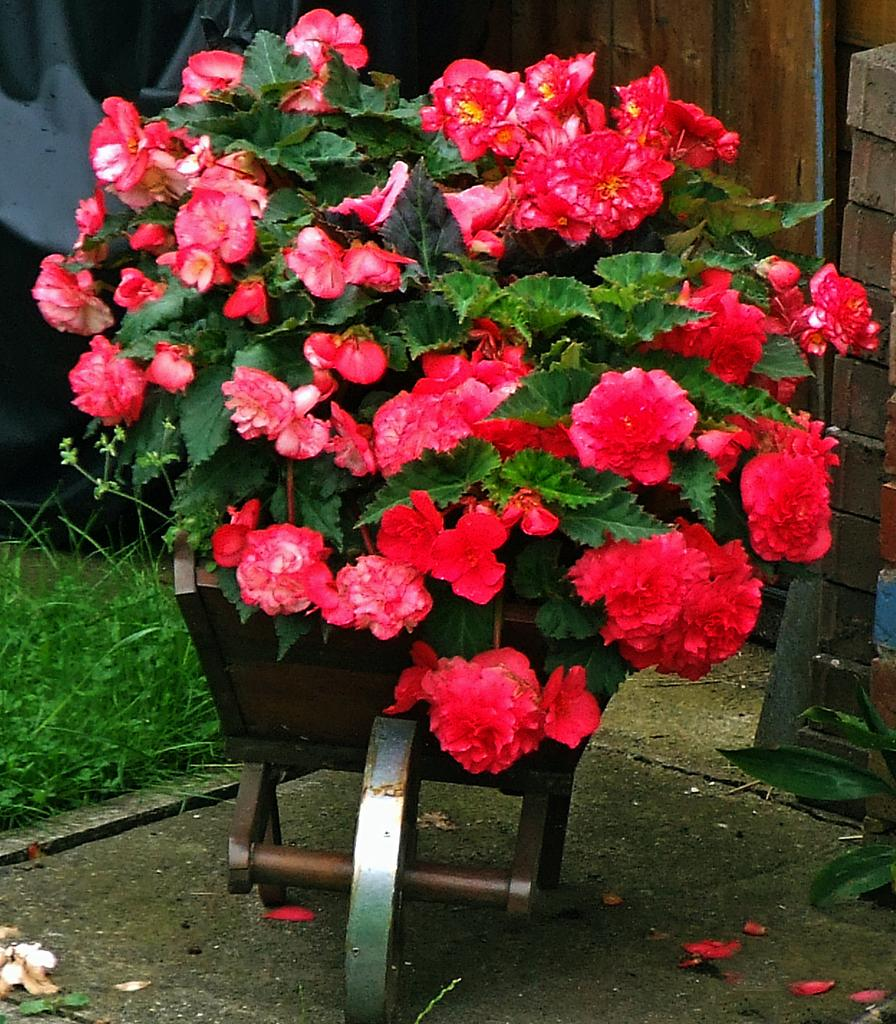What types of living organisms are in the image? There are flowers and plants in the image. How are the flowers and plants arranged in the image? The flowers and plants are in a pulley. What can be seen in the background of the image? There is a wall, bricks, and grass in the background of the image. What type of bed can be seen in the image? There is no bed present in the image. 